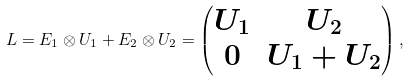<formula> <loc_0><loc_0><loc_500><loc_500>L = E _ { 1 } \otimes U _ { 1 } + E _ { 2 } \otimes U _ { 2 } = \begin{pmatrix} U _ { 1 } & U _ { 2 } \\ 0 & U _ { 1 } + U _ { 2 } \end{pmatrix} ,</formula> 